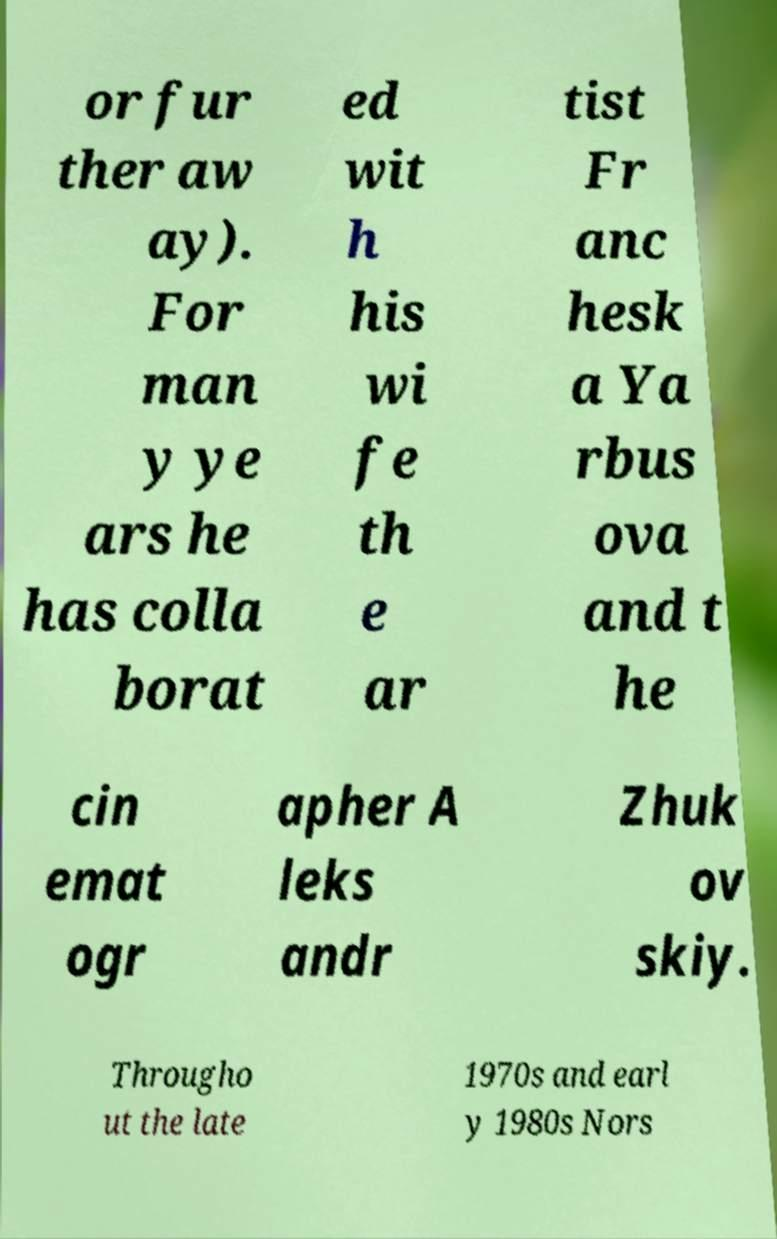For documentation purposes, I need the text within this image transcribed. Could you provide that? or fur ther aw ay). For man y ye ars he has colla borat ed wit h his wi fe th e ar tist Fr anc hesk a Ya rbus ova and t he cin emat ogr apher A leks andr Zhuk ov skiy. Througho ut the late 1970s and earl y 1980s Nors 